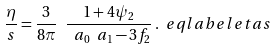Convert formula to latex. <formula><loc_0><loc_0><loc_500><loc_500>\frac { \eta } { s } = \frac { 3 } { 8 \pi } \ \frac { 1 + 4 \psi _ { 2 } } { \ a _ { 0 } \ a _ { 1 } - 3 f _ { 2 } } \, . \ e q l a b e l { e t a s }</formula> 